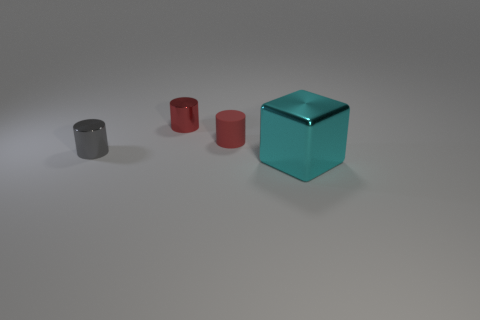What number of other small matte things are the same shape as the matte object?
Ensure brevity in your answer.  0. There is a tiny cylinder in front of the tiny rubber cylinder; is its color the same as the large thing?
Ensure brevity in your answer.  No. There is a metal thing that is behind the small shiny cylinder to the left of the small shiny object that is on the right side of the small gray object; what is its shape?
Keep it short and to the point. Cylinder. Does the cyan object have the same size as the shiny cylinder to the left of the red metal object?
Your answer should be compact. No. Is there a blue shiny ball of the same size as the cyan metal block?
Provide a succinct answer. No. How many other things are there of the same material as the large cyan object?
Give a very brief answer. 2. There is a metallic object that is both to the right of the gray metallic object and behind the large metal cube; what is its color?
Ensure brevity in your answer.  Red. Is the tiny object that is behind the rubber thing made of the same material as the object that is in front of the gray shiny thing?
Give a very brief answer. Yes. Does the metallic thing that is in front of the gray cylinder have the same size as the red shiny cylinder?
Your answer should be compact. No. Do the matte object and the tiny thing behind the red matte cylinder have the same color?
Make the answer very short. Yes. 